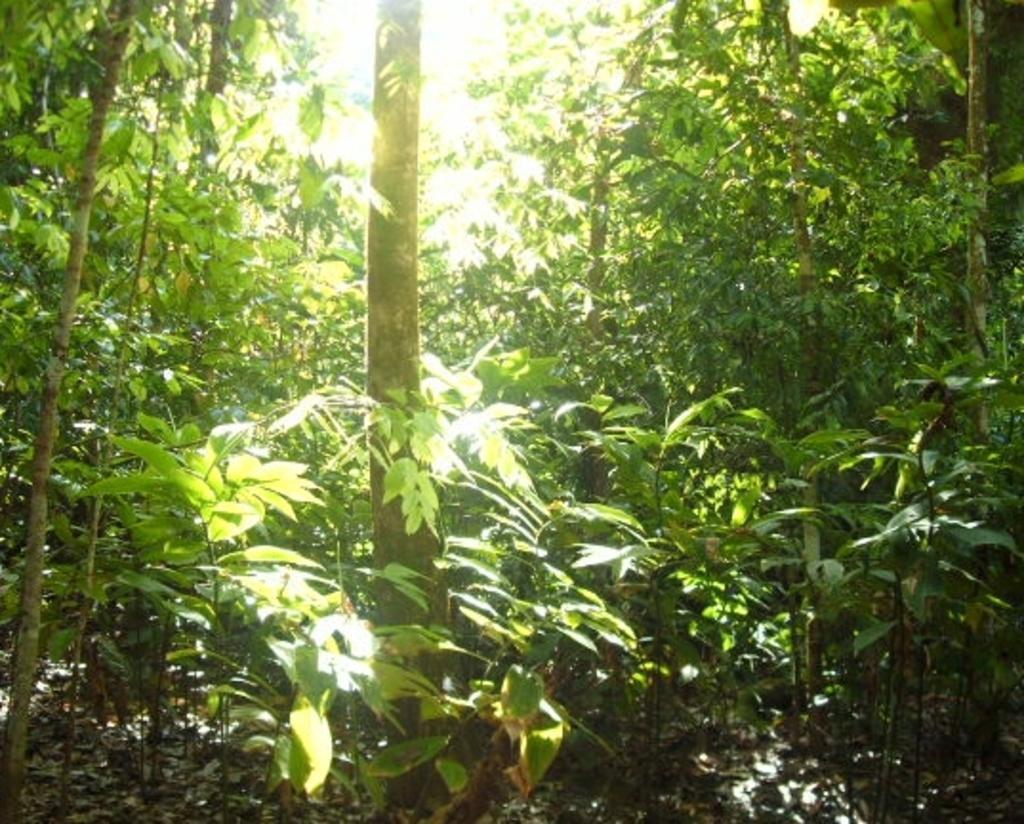Please provide a concise description of this image. In this image there are trees and there are leaves on the ground. 